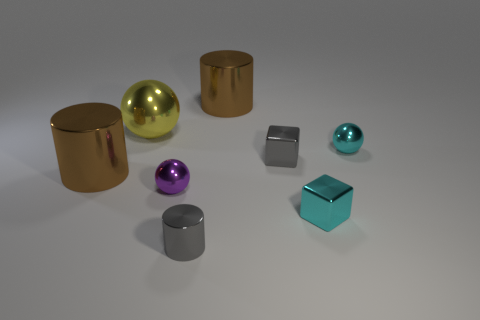What number of blocks are gray things or large metal objects?
Provide a short and direct response. 1. Is there a gray cube?
Your answer should be compact. Yes. What number of other things are made of the same material as the cyan block?
Ensure brevity in your answer.  7. What is the material of the purple object that is the same size as the gray metallic cylinder?
Give a very brief answer. Metal. There is a tiny cyan thing behind the tiny cyan metal cube; is its shape the same as the yellow object?
Offer a terse response. Yes. Is the large shiny ball the same color as the tiny cylinder?
Give a very brief answer. No. What number of things are shiny cubes that are left of the tiny cyan block or tiny metallic cylinders?
Provide a succinct answer. 2. There is a gray object that is the same size as the gray cylinder; what is its shape?
Ensure brevity in your answer.  Cube. Does the brown object on the right side of the gray shiny cylinder have the same size as the yellow shiny object that is behind the purple sphere?
Provide a short and direct response. Yes. There is a large sphere that is the same material as the gray cylinder; what color is it?
Your response must be concise. Yellow. 